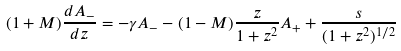<formula> <loc_0><loc_0><loc_500><loc_500>( 1 + M ) \frac { d A _ { - } } { d z } = - \gamma A _ { - } - ( 1 - M ) \frac { z } { 1 + z ^ { 2 } } A _ { + } + \frac { s } { ( 1 + z ^ { 2 } ) ^ { 1 / 2 } }</formula> 